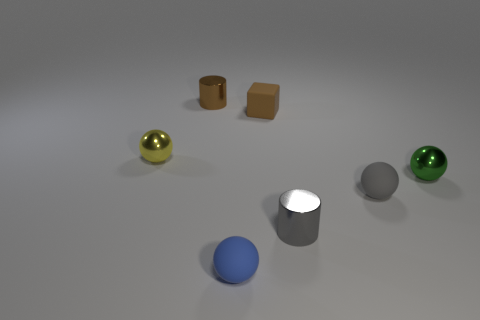The green shiny object that is the same shape as the tiny yellow metallic thing is what size?
Ensure brevity in your answer.  Small. Is there a large matte ball of the same color as the matte cube?
Offer a very short reply. No. What number of tiny spheres have the same color as the small rubber cube?
Ensure brevity in your answer.  0. How many objects are either matte things that are in front of the tiny green sphere or tiny brown matte blocks?
Make the answer very short. 3. There is another cylinder that is made of the same material as the gray cylinder; what color is it?
Make the answer very short. Brown. Is there a gray rubber thing that has the same size as the green metal object?
Give a very brief answer. Yes. How many objects are either gray rubber balls that are on the left side of the green metal thing or small things that are behind the yellow sphere?
Offer a very short reply. 3. The gray metal thing that is the same size as the blue matte thing is what shape?
Ensure brevity in your answer.  Cylinder. Is there a tiny green thing that has the same shape as the gray rubber thing?
Offer a terse response. Yes. Is the number of yellow metal balls less than the number of large green rubber spheres?
Provide a succinct answer. No. 